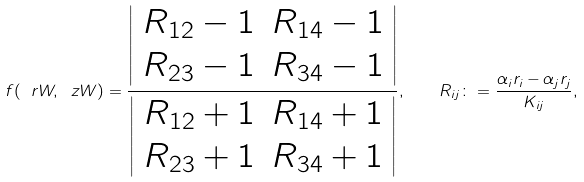<formula> <loc_0><loc_0><loc_500><loc_500>f ( \ r W , \ z W ) = \frac { \left | \begin{array} { c c } R _ { 1 2 } - 1 & R _ { 1 4 } - 1 \\ R _ { 2 3 } - 1 & R _ { 3 4 } - 1 \end{array} \right | } { \left | \begin{array} { c c } R _ { 1 2 } + 1 & R _ { 1 4 } + 1 \\ R _ { 2 3 } + 1 & R _ { 3 4 } + 1 \end{array} \right | } , \quad R _ { i j } \colon = \frac { \alpha _ { i } r _ { i } - \alpha _ { j } r _ { j } } { K _ { i j } } ,</formula> 